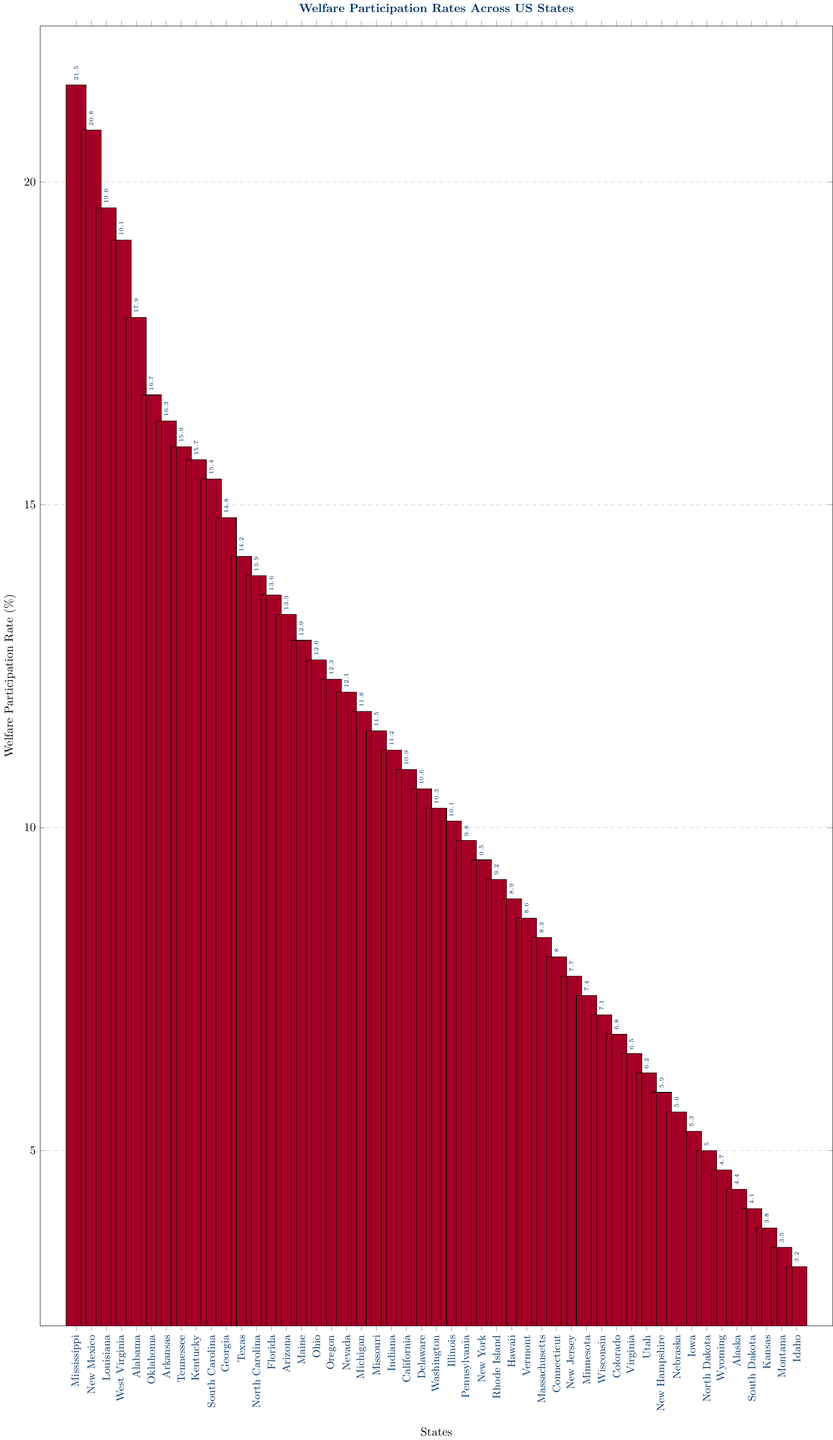Which state has the highest welfare participation rate? By examining the height of the bars, we can see that the bar corresponding to Mississippi is the highest.
Answer: Mississippi What is the welfare participation rate difference between New Mexico and Idaho? Locate the bar for New Mexico and see its value (20.8%), then locate the bar for Idaho and see its value (3.2%). Subtract the lower value from the higher one: 20.8% - 3.2% = 17.6%.
Answer: 17.6% Which state has a welfare participation rate closest to 10%? Identify the bar with a value nearest to 10%. The bar corresponding to Illinois has a rate of 10.1%, which is the closest to 10%.
Answer: Illinois List the states with welfare participation rates above 20%. Look at all the bars and identify the ones with values above 20%. Only Mississippi (21.5%) meets this criterion.
Answer: Mississippi How does the welfare participation rate of Texas compare to that of California? Locate the bars for Texas (14.2%) and California (10.9%). Texas has a higher welfare participation rate than California.
Answer: Texas has a higher rate What is the average welfare participation rate for Alabama, Oklahoma, and Arkansas? Find the rates for Alabama (17.9%), Oklahoma (16.7%), and Arkansas (16.3%). Sum them up: 17.9 + 16.7 + 16.3 = 50.9. Divide by the number of states: 50.9 / 3 = 16.97%.
Answer: 16.97% Among the states with a welfare participation rate below 5%, which has the lowest rate? Identify bars with values below 5% and find the smallest one. Idaho has a rate of 3.2%, which is the lowest among those states.
Answer: Idaho How many states have a welfare participation rate higher than the national average if the national average is 10%? Count the number of bars with values greater than 10%. Altogether, there are 23 bars with rates higher than 10%.
Answer: 23 states What is the difference in welfare participation rates between the highest and lowest states? Identify the highest rate (Mississippi, 21.5%) and the lowest rate (Idaho, 3.2%). Subtract the lower value from the higher one: 21.5% - 3.2% = 18.3%.
Answer: 18.3% Is the welfare participation rate of Georgia higher than that of Florida? Locate the bars for Georgia (14.8%) and Florida (13.6%). The rate for Georgia is higher than Florida's.
Answer: Yes 